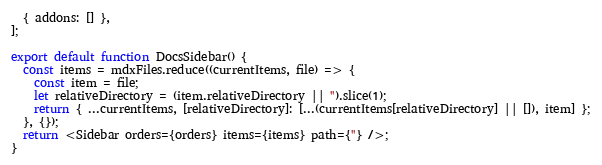Convert code to text. <code><loc_0><loc_0><loc_500><loc_500><_TypeScript_>  { addons: [] },
];

export default function DocsSidebar() {
  const items = mdxFiles.reduce((currentItems, file) => {
    const item = file;
    let relativeDirectory = (item.relativeDirectory || '').slice(1);
    return { ...currentItems, [relativeDirectory]: [...(currentItems[relativeDirectory] || []), item] };
  }, {});
  return <Sidebar orders={orders} items={items} path={''} />;
}
</code> 